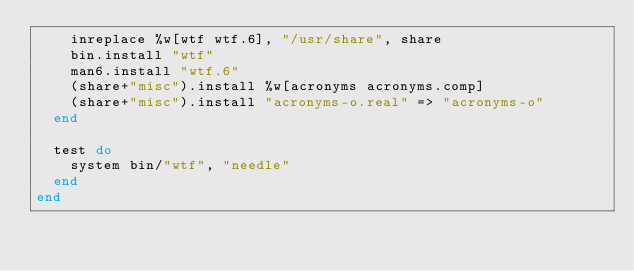Convert code to text. <code><loc_0><loc_0><loc_500><loc_500><_Ruby_>    inreplace %w[wtf wtf.6], "/usr/share", share
    bin.install "wtf"
    man6.install "wtf.6"
    (share+"misc").install %w[acronyms acronyms.comp]
    (share+"misc").install "acronyms-o.real" => "acronyms-o"
  end

  test do
    system bin/"wtf", "needle"
  end
end
</code> 